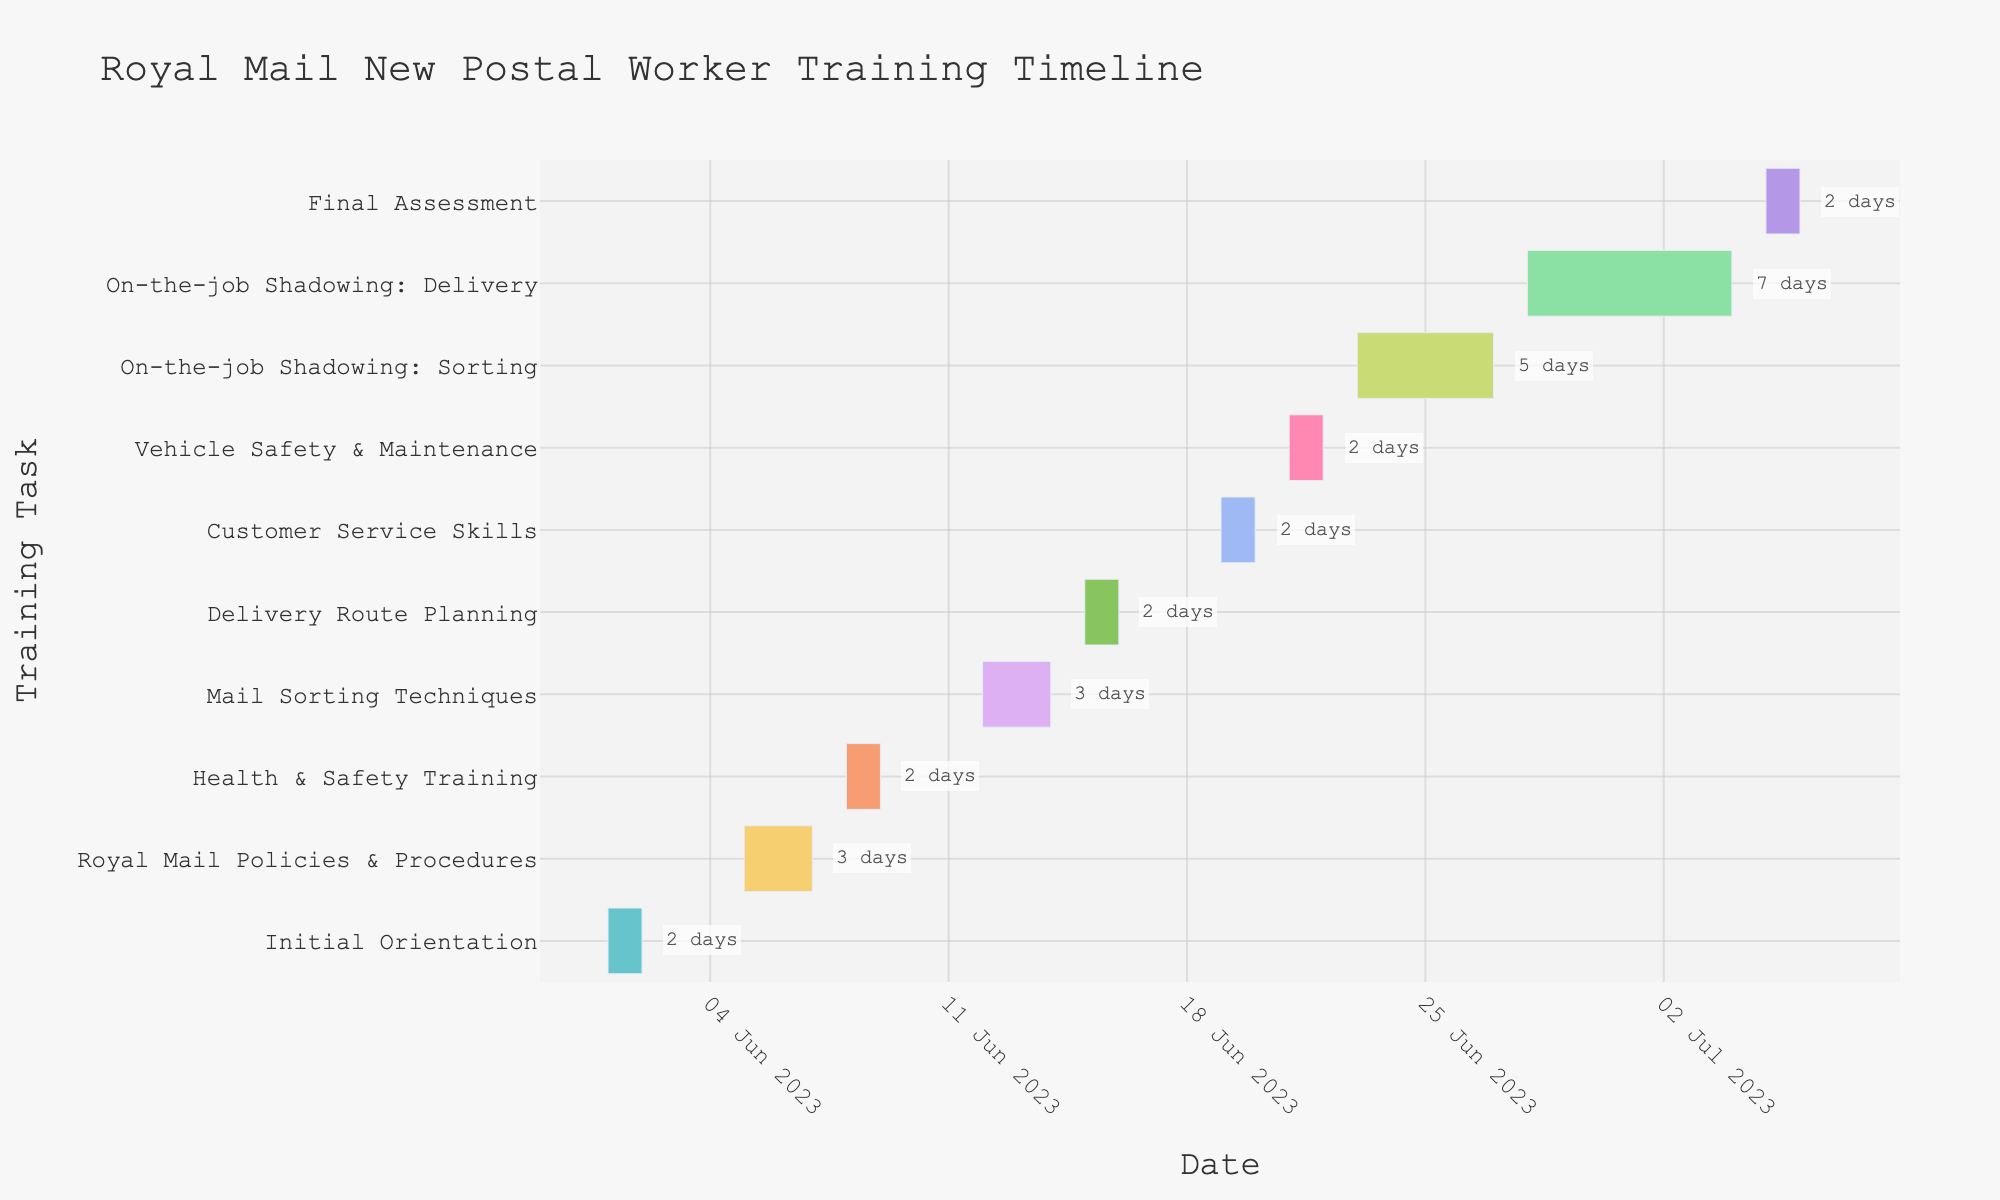What's the title of the Gantt Chart? The title is usually displayed at the top of the chart.
Answer: Royal Mail New Postal Worker Training Timeline What is the duration of the 'Health & Safety Training' task? Look at the bar representing 'Health & Safety Training' and check for the duration annotation or calculate the days from Start Date to End Date.
Answer: 2 days Which training task lasts the longest? Compare the duration annotations for each task and identify the one with the highest duration.
Answer: On-the-job Shadowing: Delivery When does the 'Customer Service Skills' task start and end? Find the 'Customer Service Skills' task on the y-axis and check its corresponding start and end dates on the x-axis.
Answer: 2023-06-19 to 2023-06-20 Which task occurs directly after 'Mail Sorting Techniques'? Check the end date of 'Mail Sorting Techniques' and identify the task that starts immediately after.
Answer: Delivery Route Planning What is the combined duration of 'Royal Mail Policies & Procedures' and 'Mail Sorting Techniques'? Add the durations of both tasks by checking their duration annotations or calculating from their start and end dates.
Answer: 6 days How many tasks start in the month of June? Count the number of tasks whose start dates fall within June.
Answer: 10 tasks Between 'Vehicle Safety & Maintenance' and 'Final Assessment,' which one is shorter in duration? Compare the duration annotations of both tasks or calculate the difference in their durations.
Answer: Final Assessment How much overlap is there between 'On-the-job Shadowing: Sorting' and 'On-the-job Shadowing: Delivery'? Calculate the number of overlapping days between the start of 'On-the-job Shadowing: Delivery' and the end of 'On-the-job Shadowing: Sorting.'
Answer: 3 days Do any tasks occur over the weekend (Saturday and Sunday)? Verify if any task has its start or end date on a weekend by checking the specific dates in the timeline.
Answer: Yes, On-the-job Shadowing: Sorting overlaps a weekend 